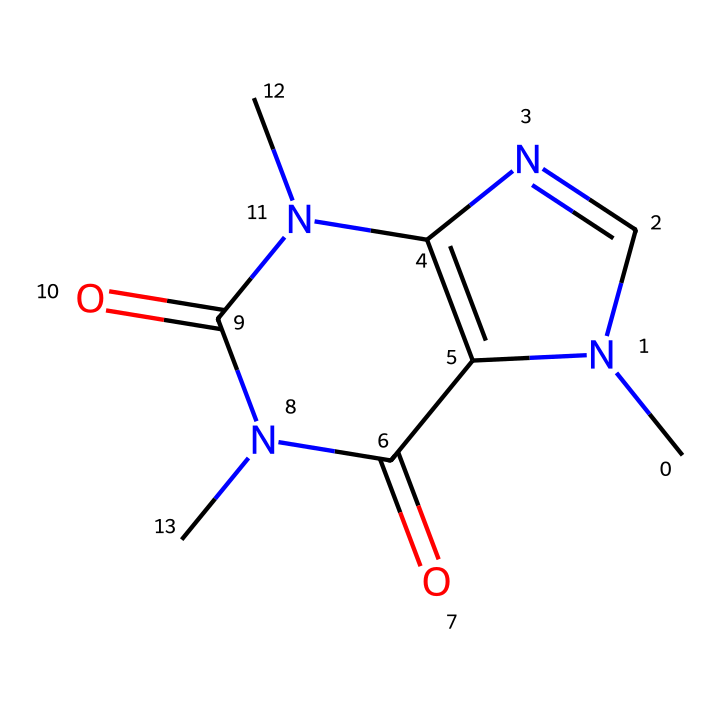What is the main alkaloid represented in the structure? The SMILES representation corresponds to caffeine, a well-known alkaloid commonly found in various plants. Identifying the name involves recognizing the chemical structure, which contains specific features typical of caffeine.
Answer: caffeine How many nitrogen atoms are present in this chemical structure? By analyzing the SMILES notation, there are three distinct nitrogen atoms illustrated in the structure. Counting each nitrogen results in the total.
Answer: three What type of functional groups are present in this molecule? The chemical structure includes amide functional groups due to the -C(=O)N- connections found in the SMILES representation. Identifying these requires examining the connecting atoms and their bonding.
Answer: amide What is the hybridization of the central nitrogen atom in this structure? The central nitrogen atom is involved in forming planar structures, indicative of sp2 hybridization. This is determined by examining the bonds and angles connected to the nitrogen.
Answer: sp2 Does this compound have any aromatic rings? The structure does not indicate the presence of aromatic rings as it lacks the characteristics of cyclic compounds with delocalized pi electrons. Analyzing the connections reveals no double bonds in a cyclic arrangement typically associated with aromatic systems.
Answer: no How many carbon atoms are present in this molecule? A careful count of the carbon atoms represented in the SMILES notation reveals a total of six carbon atoms, which can be identified by their connections to other atoms in the structure.
Answer: six 